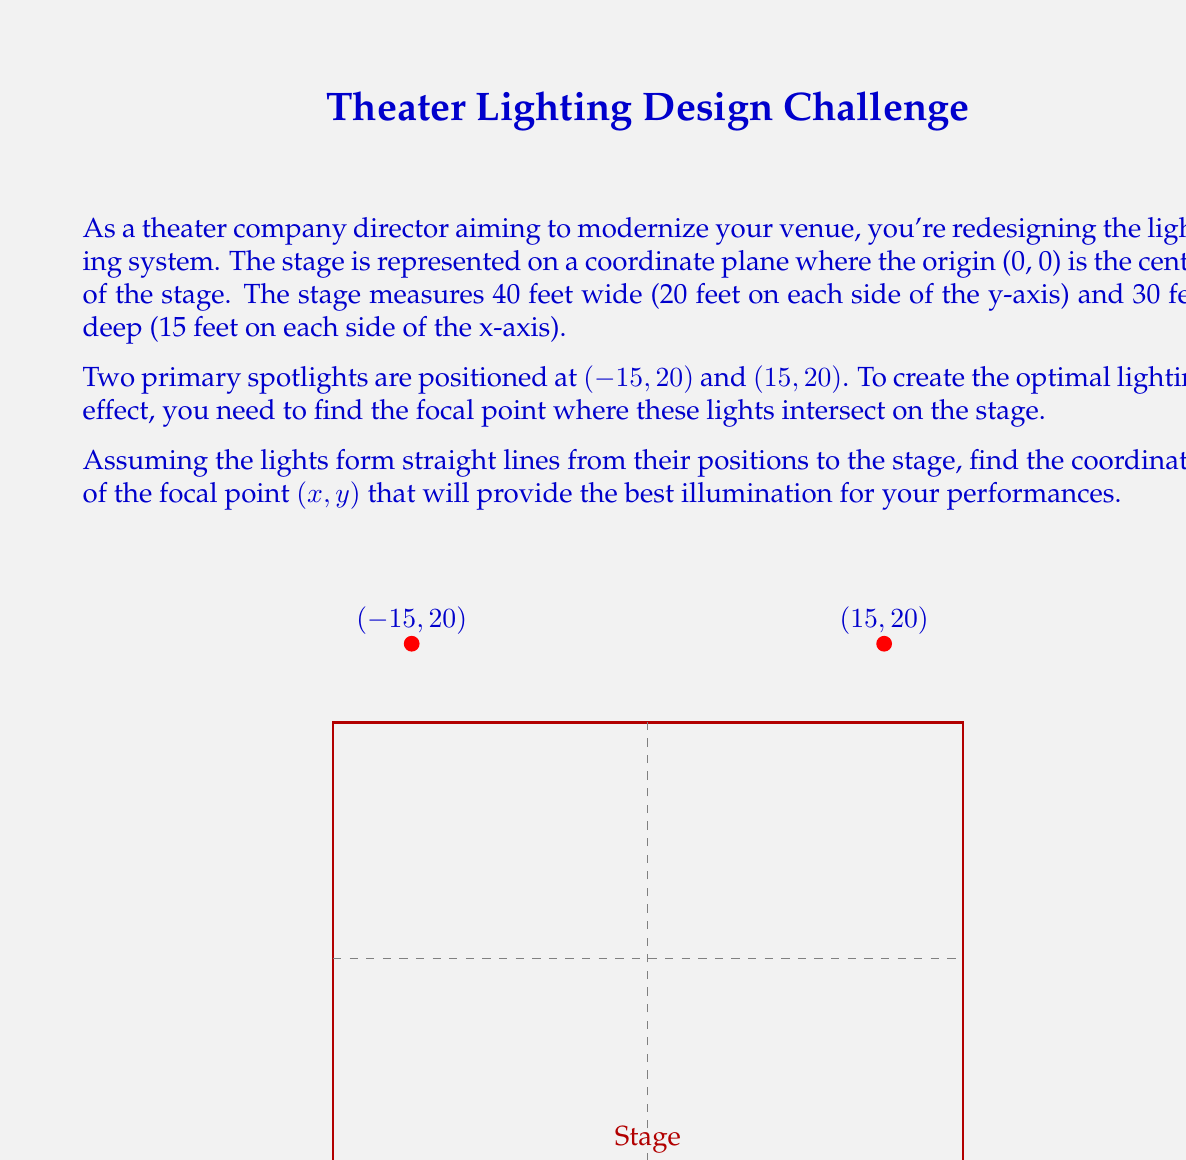Give your solution to this math problem. Let's approach this step-by-step:

1) The two spotlights form two lines that intersect at the focal point. We can use the point-slope form of a line to find their equations.

2) For the spotlight at (-15, 20), the slope is:
   $$m_1 = \frac{20 - y}{-15 - x}$$

3) For the spotlight at (15, 20), the slope is:
   $$m_2 = \frac{20 - y}{15 - x}$$

4) At the intersection point (x, y), both equations are true:
   $$\frac{20 - y}{-15 - x} = \frac{20 - y}{15 - x}$$

5) Cross-multiplying:
   $$(20 - y)(15 - x) = (20 - y)(-15 - x)$$

6) Expanding:
   $$300 - 15y - 20x + xy = -300 + 15y + 20x - xy$$

7) Simplifying:
   $$600 - 30y - 40x + 2xy = 0$$

8) Factoring out 2:
   $$2(300 - 15y - 20x + xy) = 0$$

9) Dividing by 2:
   $$300 - 15y - 20x + xy = 0$$

10) Solving for y:
    $$y(x - 15) = 20x - 300$$
    $$y = \frac{20x - 300}{x - 15}$$

11) Due to the symmetry of the stage and light positions, we know that x = 0.

12) Substituting x = 0 into our equation for y:
    $$y = \frac{20(0) - 300}{0 - 15} = \frac{-300}{-15} = 20$$

Therefore, the focal point is at (0, 20).
Answer: (0, 20) 